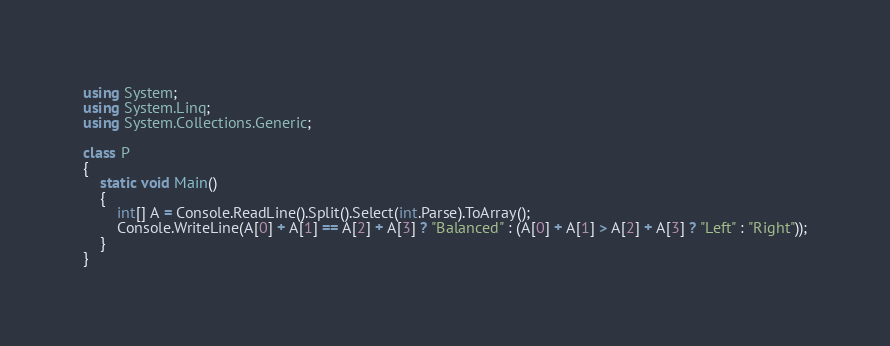Convert code to text. <code><loc_0><loc_0><loc_500><loc_500><_C#_>using System;
using System.Linq;
using System.Collections.Generic;

class P
{
    static void Main()
    {
        int[] A = Console.ReadLine().Split().Select(int.Parse).ToArray();
        Console.WriteLine(A[0] + A[1] == A[2] + A[3] ? "Balanced" : (A[0] + A[1] > A[2] + A[3] ? "Left" : "Right"));
    }
}</code> 